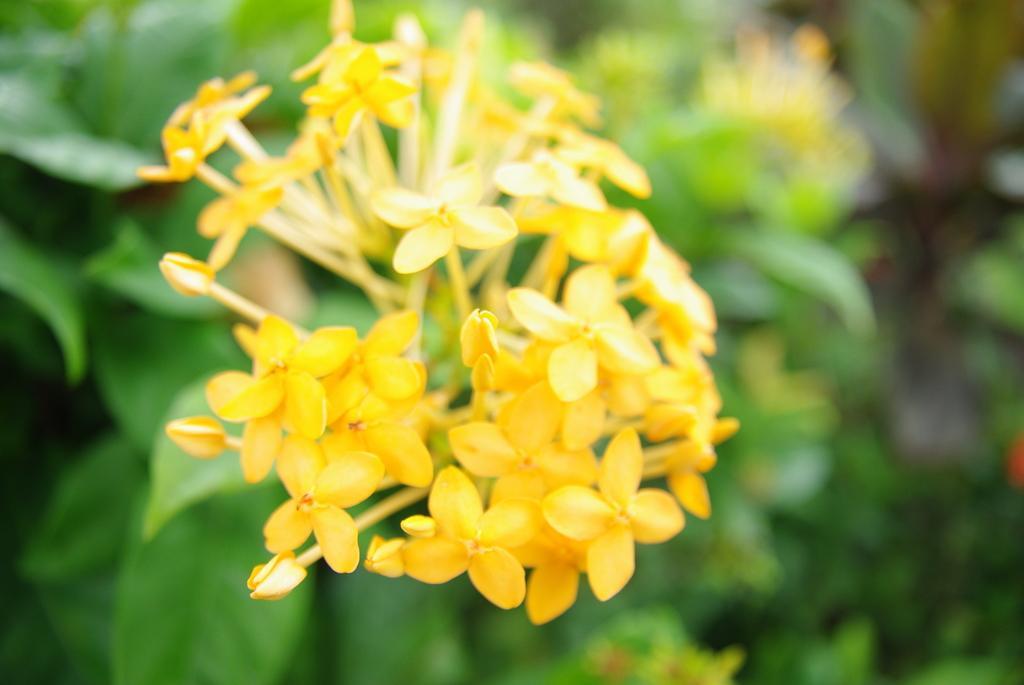In one or two sentences, can you explain what this image depicts? In the center of this picture we can see the yellow color flowers. In the background we can see the plants and some other objects. 